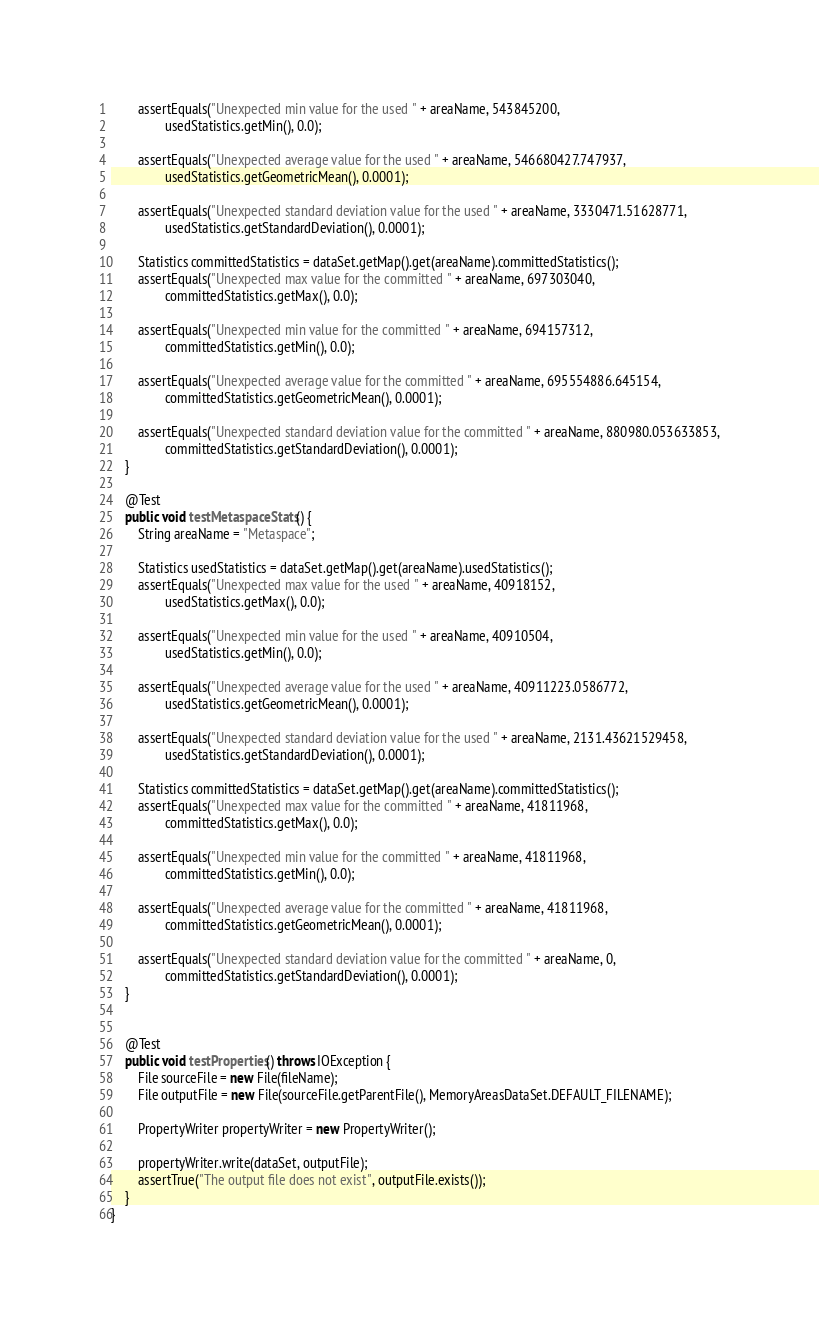<code> <loc_0><loc_0><loc_500><loc_500><_Java_>        assertEquals("Unexpected min value for the used " + areaName, 543845200,
                usedStatistics.getMin(), 0.0);

        assertEquals("Unexpected average value for the used " + areaName, 546680427.747937,
                usedStatistics.getGeometricMean(), 0.0001);

        assertEquals("Unexpected standard deviation value for the used " + areaName, 3330471.51628771,
                usedStatistics.getStandardDeviation(), 0.0001);

        Statistics committedStatistics = dataSet.getMap().get(areaName).committedStatistics();
        assertEquals("Unexpected max value for the committed " + areaName, 697303040,
                committedStatistics.getMax(), 0.0);

        assertEquals("Unexpected min value for the committed " + areaName, 694157312,
                committedStatistics.getMin(), 0.0);

        assertEquals("Unexpected average value for the committed " + areaName, 695554886.645154,
                committedStatistics.getGeometricMean(), 0.0001);

        assertEquals("Unexpected standard deviation value for the committed " + areaName, 880980.053633853,
                committedStatistics.getStandardDeviation(), 0.0001);
    }

    @Test
    public void testMetaspaceStats() {
        String areaName = "Metaspace";

        Statistics usedStatistics = dataSet.getMap().get(areaName).usedStatistics();
        assertEquals("Unexpected max value for the used " + areaName, 40918152,
                usedStatistics.getMax(), 0.0);

        assertEquals("Unexpected min value for the used " + areaName, 40910504,
                usedStatistics.getMin(), 0.0);

        assertEquals("Unexpected average value for the used " + areaName, 40911223.0586772,
                usedStatistics.getGeometricMean(), 0.0001);

        assertEquals("Unexpected standard deviation value for the used " + areaName, 2131.43621529458,
                usedStatistics.getStandardDeviation(), 0.0001);

        Statistics committedStatistics = dataSet.getMap().get(areaName).committedStatistics();
        assertEquals("Unexpected max value for the committed " + areaName, 41811968,
                committedStatistics.getMax(), 0.0);

        assertEquals("Unexpected min value for the committed " + areaName, 41811968,
                committedStatistics.getMin(), 0.0);

        assertEquals("Unexpected average value for the committed " + areaName, 41811968,
                committedStatistics.getGeometricMean(), 0.0001);

        assertEquals("Unexpected standard deviation value for the committed " + areaName, 0,
                committedStatistics.getStandardDeviation(), 0.0001);
    }


    @Test
    public void testProperties() throws IOException {
        File sourceFile = new File(fileName);
        File outputFile = new File(sourceFile.getParentFile(), MemoryAreasDataSet.DEFAULT_FILENAME);

        PropertyWriter propertyWriter = new PropertyWriter();

        propertyWriter.write(dataSet, outputFile);
        assertTrue("The output file does not exist", outputFile.exists());
    }
}
</code> 